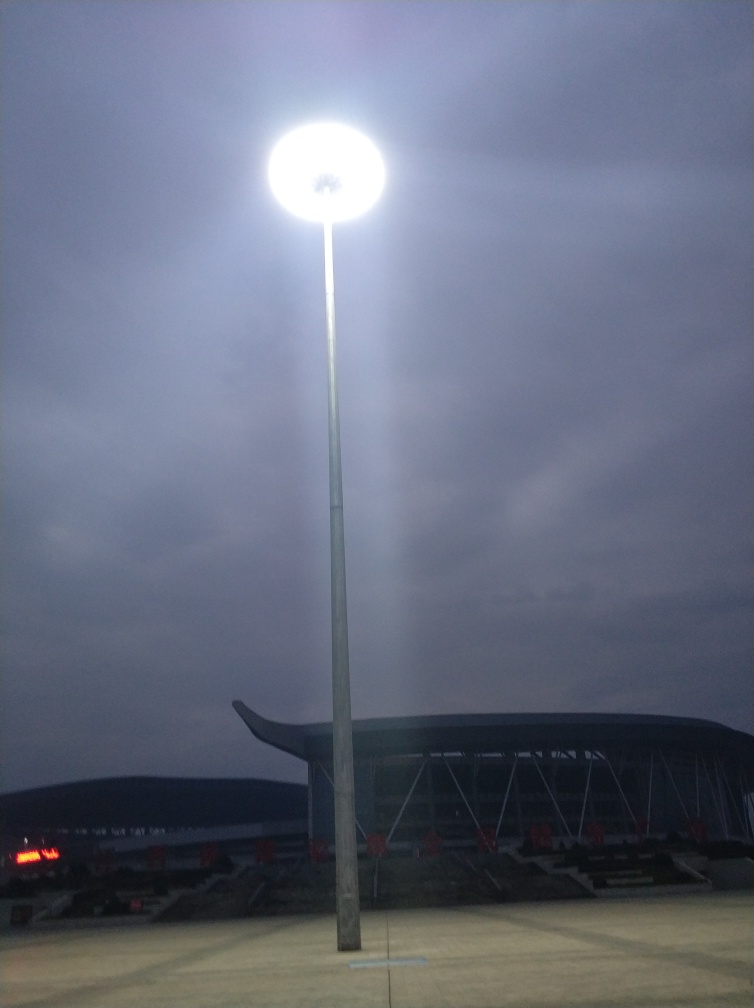How does the lighting in the image affect the ambiance of the scene? The floodlight creates a dramatic effect, with a bright focal point against the dimly lit sky. This stark contrast gives the scene a dynamic and somewhat theatrical ambiance, emphasizing the prominence of the light against the evening backdrop. 